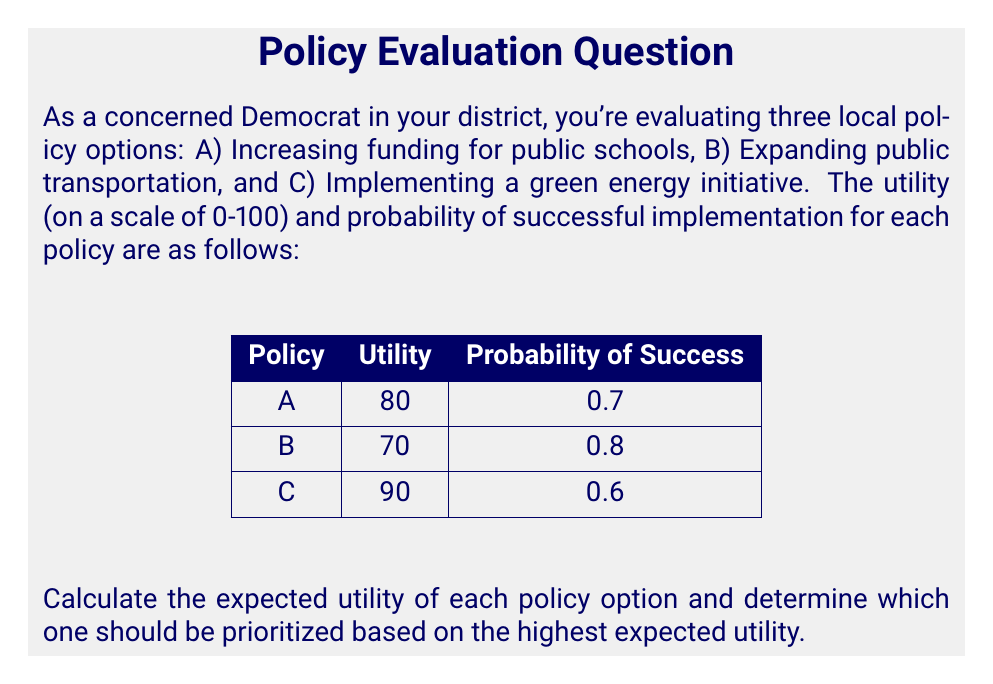Provide a solution to this math problem. To solve this problem, we need to calculate the expected utility for each policy option using the formula:

Expected Utility = Utility × Probability of Success

Let's calculate for each policy:

1. Policy A (Increasing funding for public schools):
   $EU_A = 80 \times 0.7 = 56$

2. Policy B (Expanding public transportation):
   $EU_B = 70 \times 0.8 = 56$

3. Policy C (Implementing a green energy initiative):
   $EU_C = 90 \times 0.6 = 54$

Now, let's compare the expected utilities:

$$\begin{array}{|c|c|}
\hline
\text{Policy} & \text{Expected Utility} \\
\hline
\text{A} & 56 \\
\hline
\text{B} & 56 \\
\hline
\text{C} & 54 \\
\hline
\end{array}$$

We can see that policies A and B have the highest expected utility of 56, while policy C has a slightly lower expected utility of 54.
Answer: Prioritize policies A and B (tied at 56). 